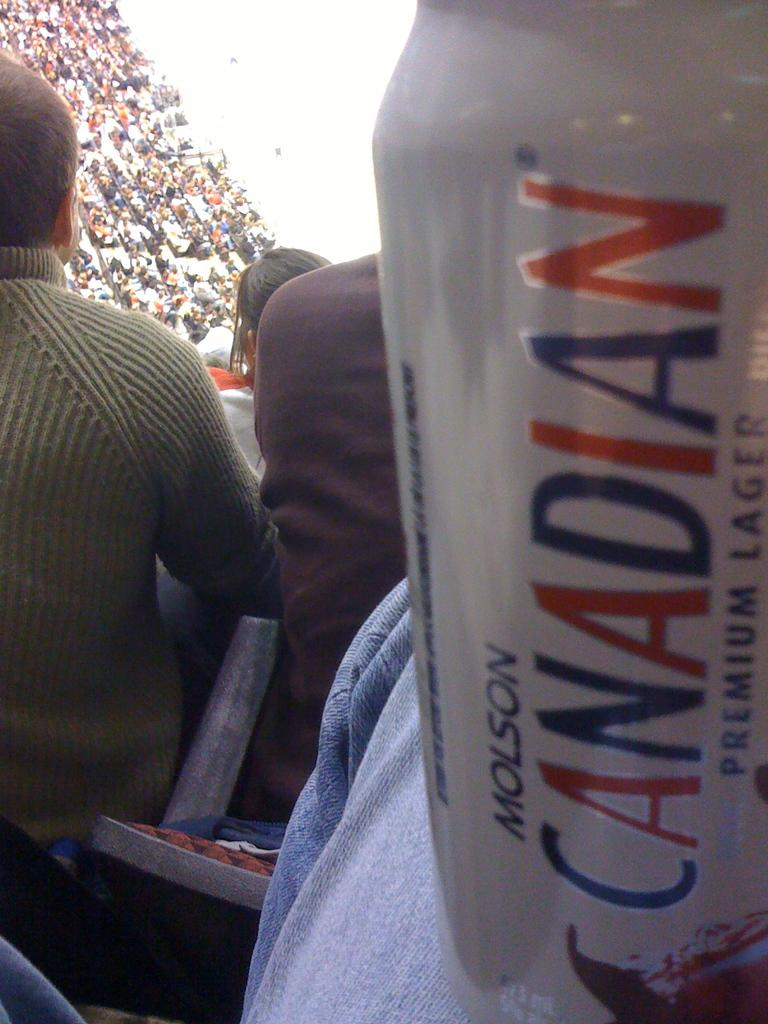Where was the image taken? The image was taken in a stadium. What can be seen on the left side of the image? There are people sitting on chairs on the left side of the image. What is present on the right side of the image? There is a can with text on the right side of the image. What type of humor is being expressed by the bag in the image? There is no bag present in the image, so it is not possible to determine any humor being expressed. 